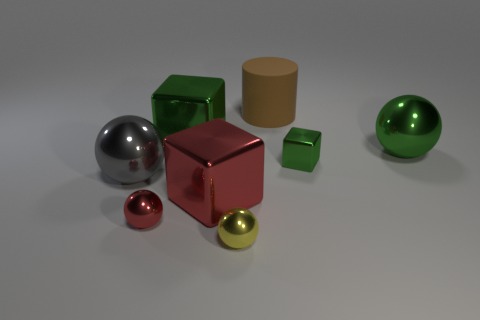What time of day does the lighting in the image suggest? The lighting in the image is diffuse and does not strongly indicate any specific time of day. It resembles soft box lighting, which is a type of artificial light commonly used in a photography studio, suggesting that the image might have been taken indoors under controlled lighting conditions. 